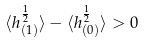<formula> <loc_0><loc_0><loc_500><loc_500>\langle h _ { ( 1 ) } ^ { \frac { 1 } { 2 } } \rangle - \langle h _ { ( 0 ) } ^ { \frac { 1 } { 2 } } \rangle > 0</formula> 